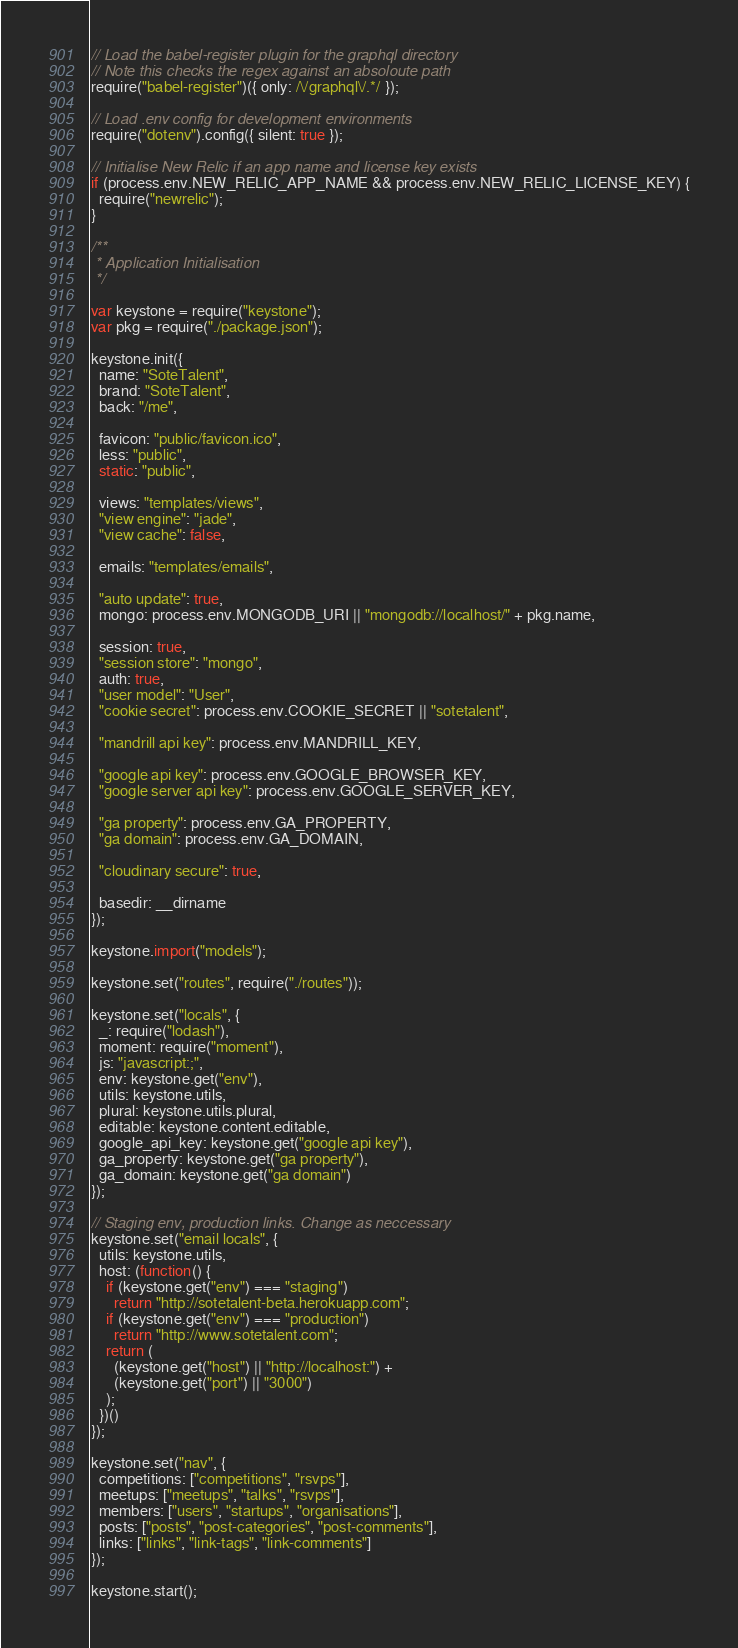<code> <loc_0><loc_0><loc_500><loc_500><_JavaScript_>// Load the babel-register plugin for the graphql directory
// Note this checks the regex against an absoloute path
require("babel-register")({ only: /\/graphql\/.*/ });

// Load .env config for development environments
require("dotenv").config({ silent: true });

// Initialise New Relic if an app name and license key exists
if (process.env.NEW_RELIC_APP_NAME && process.env.NEW_RELIC_LICENSE_KEY) {
  require("newrelic");
}

/**
 * Application Initialisation
 */

var keystone = require("keystone");
var pkg = require("./package.json");

keystone.init({
  name: "SoteTalent",
  brand: "SoteTalent",
  back: "/me",

  favicon: "public/favicon.ico",
  less: "public",
  static: "public",

  views: "templates/views",
  "view engine": "jade",
  "view cache": false,

  emails: "templates/emails",

  "auto update": true,
  mongo: process.env.MONGODB_URI || "mongodb://localhost/" + pkg.name,

  session: true,
  "session store": "mongo",
  auth: true,
  "user model": "User",
  "cookie secret": process.env.COOKIE_SECRET || "sotetalent",

  "mandrill api key": process.env.MANDRILL_KEY,

  "google api key": process.env.GOOGLE_BROWSER_KEY,
  "google server api key": process.env.GOOGLE_SERVER_KEY,

  "ga property": process.env.GA_PROPERTY,
  "ga domain": process.env.GA_DOMAIN,

  "cloudinary secure": true,

  basedir: __dirname
});

keystone.import("models");

keystone.set("routes", require("./routes"));

keystone.set("locals", {
  _: require("lodash"),
  moment: require("moment"),
  js: "javascript:;",
  env: keystone.get("env"),
  utils: keystone.utils,
  plural: keystone.utils.plural,
  editable: keystone.content.editable,
  google_api_key: keystone.get("google api key"),
  ga_property: keystone.get("ga property"),
  ga_domain: keystone.get("ga domain")
});

// Staging env, production links. Change as neccessary
keystone.set("email locals", {
  utils: keystone.utils,
  host: (function() {
    if (keystone.get("env") === "staging")
      return "http://sotetalent-beta.herokuapp.com";
    if (keystone.get("env") === "production")
      return "http://www.sotetalent.com";
    return (
      (keystone.get("host") || "http://localhost:") +
      (keystone.get("port") || "3000")
    );
  })()
});

keystone.set("nav", {
  competitions: ["competitions", "rsvps"],
  meetups: ["meetups", "talks", "rsvps"],
  members: ["users", "startups", "organisations"],
  posts: ["posts", "post-categories", "post-comments"],
  links: ["links", "link-tags", "link-comments"]
});

keystone.start();
</code> 